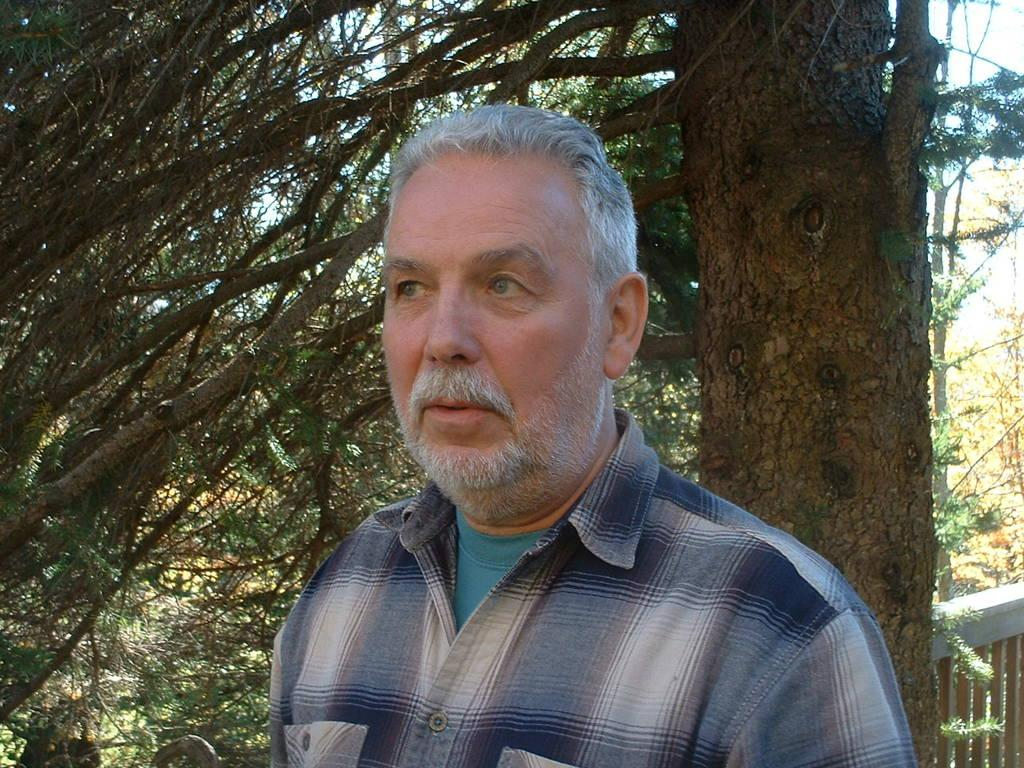Who is the main subject in the picture? There is an old man in the picture. What is the old man wearing? The old man is wearing a blue and white shirt. Where is the old man positioned in the image? The old man is standing in the front of the image. What type of object can be seen in the image besides the old man? There is a dry tree trunk and branches visible in the image. Reasoning: Let'ing: Let's think step by step in order to produce the conversation. We start by identifying the main subject in the image, which is the old man. Then, we describe the old man's clothing and his position in the image. Next, we mention the other objects present in the image, which are the dry tree trunk and branches. Each question is designed to elicit a specific detail about the image that is known from the provided facts. Absurd Question/Answer: What type of coil is being used to answer the old man's questions in the image? There is no coil or any indication of questions being asked in the image. 